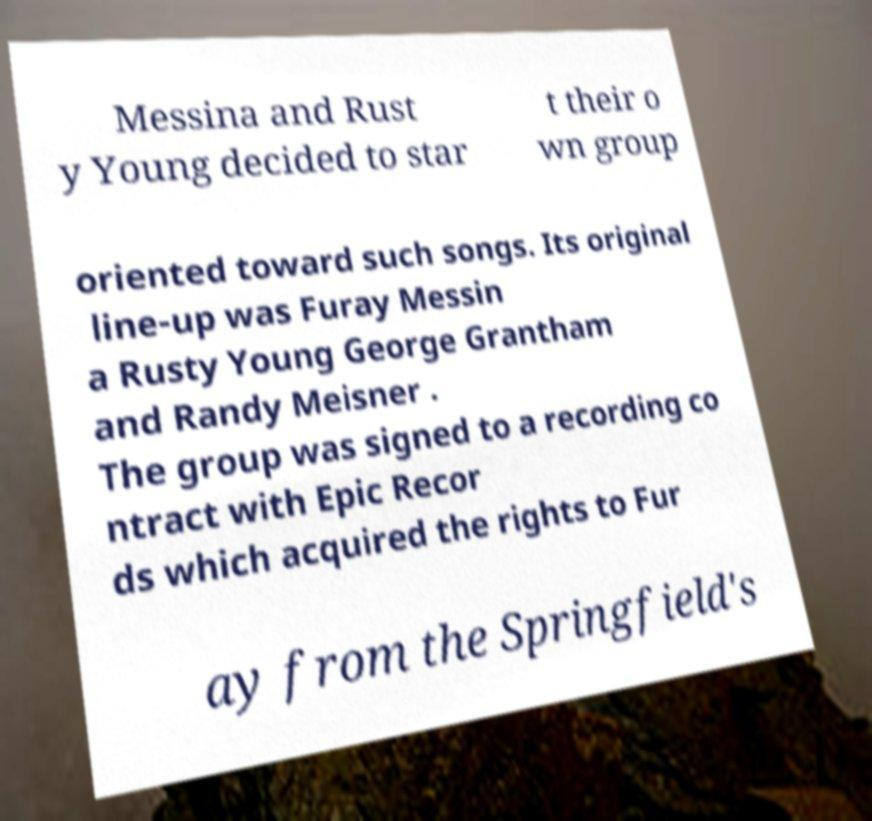Could you extract and type out the text from this image? Messina and Rust y Young decided to star t their o wn group oriented toward such songs. Its original line-up was Furay Messin a Rusty Young George Grantham and Randy Meisner . The group was signed to a recording co ntract with Epic Recor ds which acquired the rights to Fur ay from the Springfield's 